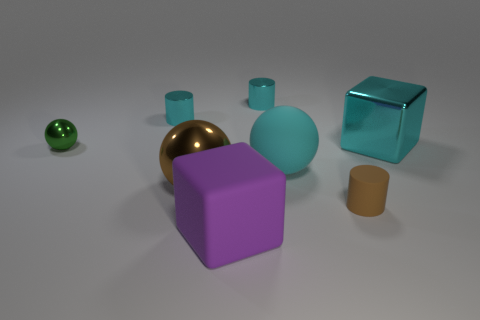Subtract all metal spheres. How many spheres are left? 1 Add 2 big things. How many objects exist? 10 Subtract all cylinders. How many objects are left? 5 Subtract all cyan blocks. How many blocks are left? 1 Subtract all green cylinders. Subtract all yellow balls. How many cylinders are left? 3 Subtract all purple spheres. How many cyan cylinders are left? 2 Subtract 1 cylinders. How many cylinders are left? 2 Subtract all purple rubber things. Subtract all big cyan rubber balls. How many objects are left? 6 Add 8 big purple blocks. How many big purple blocks are left? 9 Add 7 cyan balls. How many cyan balls exist? 8 